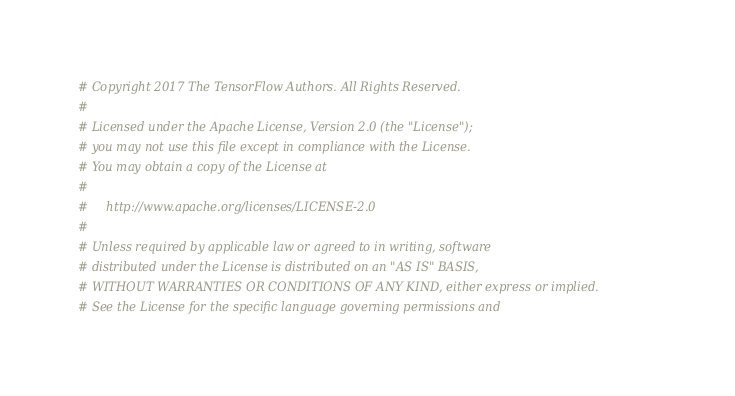<code> <loc_0><loc_0><loc_500><loc_500><_Python_># Copyright 2017 The TensorFlow Authors. All Rights Reserved.
#
# Licensed under the Apache License, Version 2.0 (the "License");
# you may not use this file except in compliance with the License.
# You may obtain a copy of the License at
#
#     http://www.apache.org/licenses/LICENSE-2.0
#
# Unless required by applicable law or agreed to in writing, software
# distributed under the License is distributed on an "AS IS" BASIS,
# WITHOUT WARRANTIES OR CONDITIONS OF ANY KIND, either express or implied.
# See the License for the specific language governing permissions and</code> 